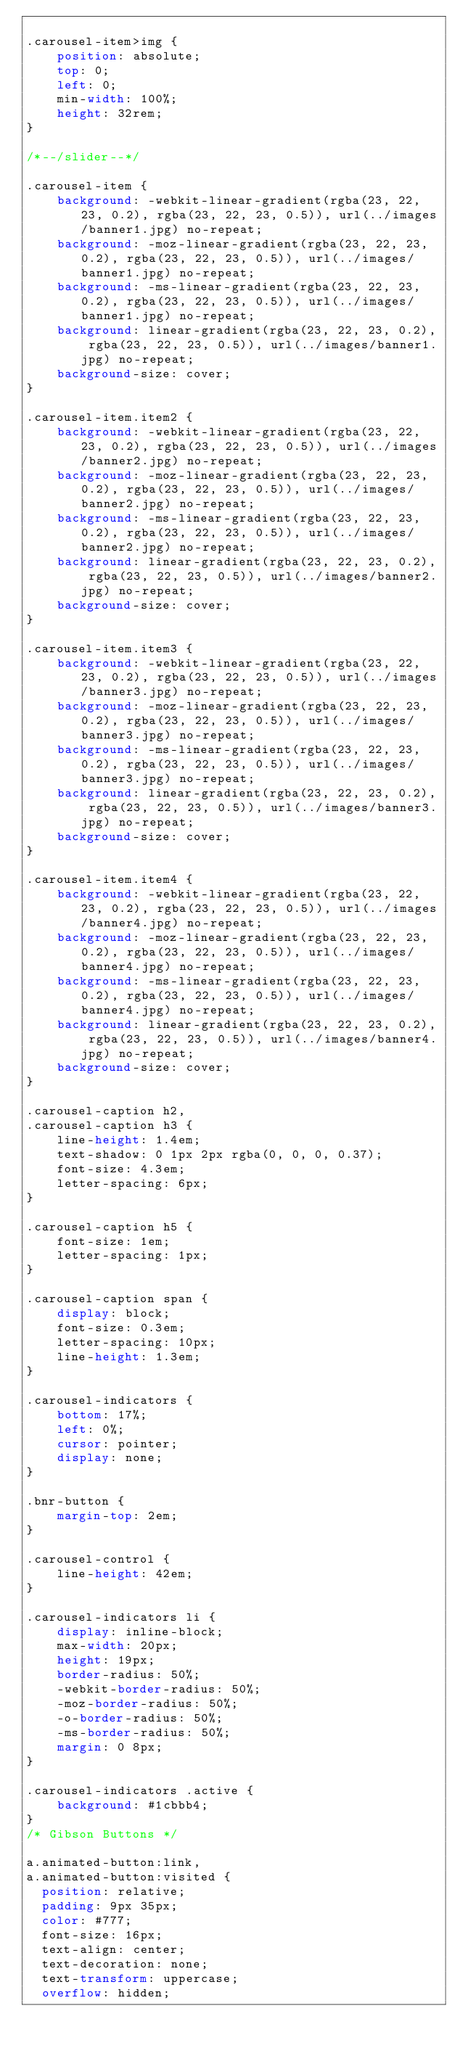<code> <loc_0><loc_0><loc_500><loc_500><_CSS_>
.carousel-item>img {
    position: absolute;
    top: 0;
    left: 0;
    min-width: 100%;
    height: 32rem;
}

/*--/slider--*/

.carousel-item {
    background: -webkit-linear-gradient(rgba(23, 22, 23, 0.2), rgba(23, 22, 23, 0.5)), url(../images/banner1.jpg) no-repeat;
    background: -moz-linear-gradient(rgba(23, 22, 23, 0.2), rgba(23, 22, 23, 0.5)), url(../images/banner1.jpg) no-repeat;
    background: -ms-linear-gradient(rgba(23, 22, 23, 0.2), rgba(23, 22, 23, 0.5)), url(../images/banner1.jpg) no-repeat;
    background: linear-gradient(rgba(23, 22, 23, 0.2), rgba(23, 22, 23, 0.5)), url(../images/banner1.jpg) no-repeat;
    background-size: cover;
}

.carousel-item.item2 {
    background: -webkit-linear-gradient(rgba(23, 22, 23, 0.2), rgba(23, 22, 23, 0.5)), url(../images/banner2.jpg) no-repeat;
    background: -moz-linear-gradient(rgba(23, 22, 23, 0.2), rgba(23, 22, 23, 0.5)), url(../images/banner2.jpg) no-repeat;
    background: -ms-linear-gradient(rgba(23, 22, 23, 0.2), rgba(23, 22, 23, 0.5)), url(../images/banner2.jpg) no-repeat;
    background: linear-gradient(rgba(23, 22, 23, 0.2), rgba(23, 22, 23, 0.5)), url(../images/banner2.jpg) no-repeat;
    background-size: cover;
}

.carousel-item.item3 {
    background: -webkit-linear-gradient(rgba(23, 22, 23, 0.2), rgba(23, 22, 23, 0.5)), url(../images/banner3.jpg) no-repeat;
    background: -moz-linear-gradient(rgba(23, 22, 23, 0.2), rgba(23, 22, 23, 0.5)), url(../images/banner3.jpg) no-repeat;
    background: -ms-linear-gradient(rgba(23, 22, 23, 0.2), rgba(23, 22, 23, 0.5)), url(../images/banner3.jpg) no-repeat;
    background: linear-gradient(rgba(23, 22, 23, 0.2), rgba(23, 22, 23, 0.5)), url(../images/banner3.jpg) no-repeat;
    background-size: cover;
}

.carousel-item.item4 {
    background: -webkit-linear-gradient(rgba(23, 22, 23, 0.2), rgba(23, 22, 23, 0.5)), url(../images/banner4.jpg) no-repeat;
    background: -moz-linear-gradient(rgba(23, 22, 23, 0.2), rgba(23, 22, 23, 0.5)), url(../images/banner4.jpg) no-repeat;
    background: -ms-linear-gradient(rgba(23, 22, 23, 0.2), rgba(23, 22, 23, 0.5)), url(../images/banner4.jpg) no-repeat;
    background: linear-gradient(rgba(23, 22, 23, 0.2), rgba(23, 22, 23, 0.5)), url(../images/banner4.jpg) no-repeat;
    background-size: cover;
}

.carousel-caption h2,
.carousel-caption h3 {
    line-height: 1.4em;
    text-shadow: 0 1px 2px rgba(0, 0, 0, 0.37);
    font-size: 4.3em;
    letter-spacing: 6px;
}

.carousel-caption h5 {
    font-size: 1em;
    letter-spacing: 1px;
}

.carousel-caption span {
    display: block;
    font-size: 0.3em;
    letter-spacing: 10px;
    line-height: 1.3em;
}

.carousel-indicators {
    bottom: 17%;
    left: 0%;
    cursor: pointer;
    display: none;
}

.bnr-button {
    margin-top: 2em;
}

.carousel-control {
    line-height: 42em;
}

.carousel-indicators li {
    display: inline-block;
    max-width: 20px;
    height: 19px;
    border-radius: 50%;
    -webkit-border-radius: 50%;
    -moz-border-radius: 50%;
    -o-border-radius: 50%;
    -ms-border-radius: 50%;
    margin: 0 8px;
}

.carousel-indicators .active {
    background: #1cbbb4;
}
/* Gibson Buttons */

a.animated-button:link,
a.animated-button:visited {
	position: relative;
	padding: 9px 35px;
	color: #777;
	font-size: 16px;
	text-align: center;
	text-decoration: none;
	text-transform: uppercase;
	overflow: hidden;</code> 